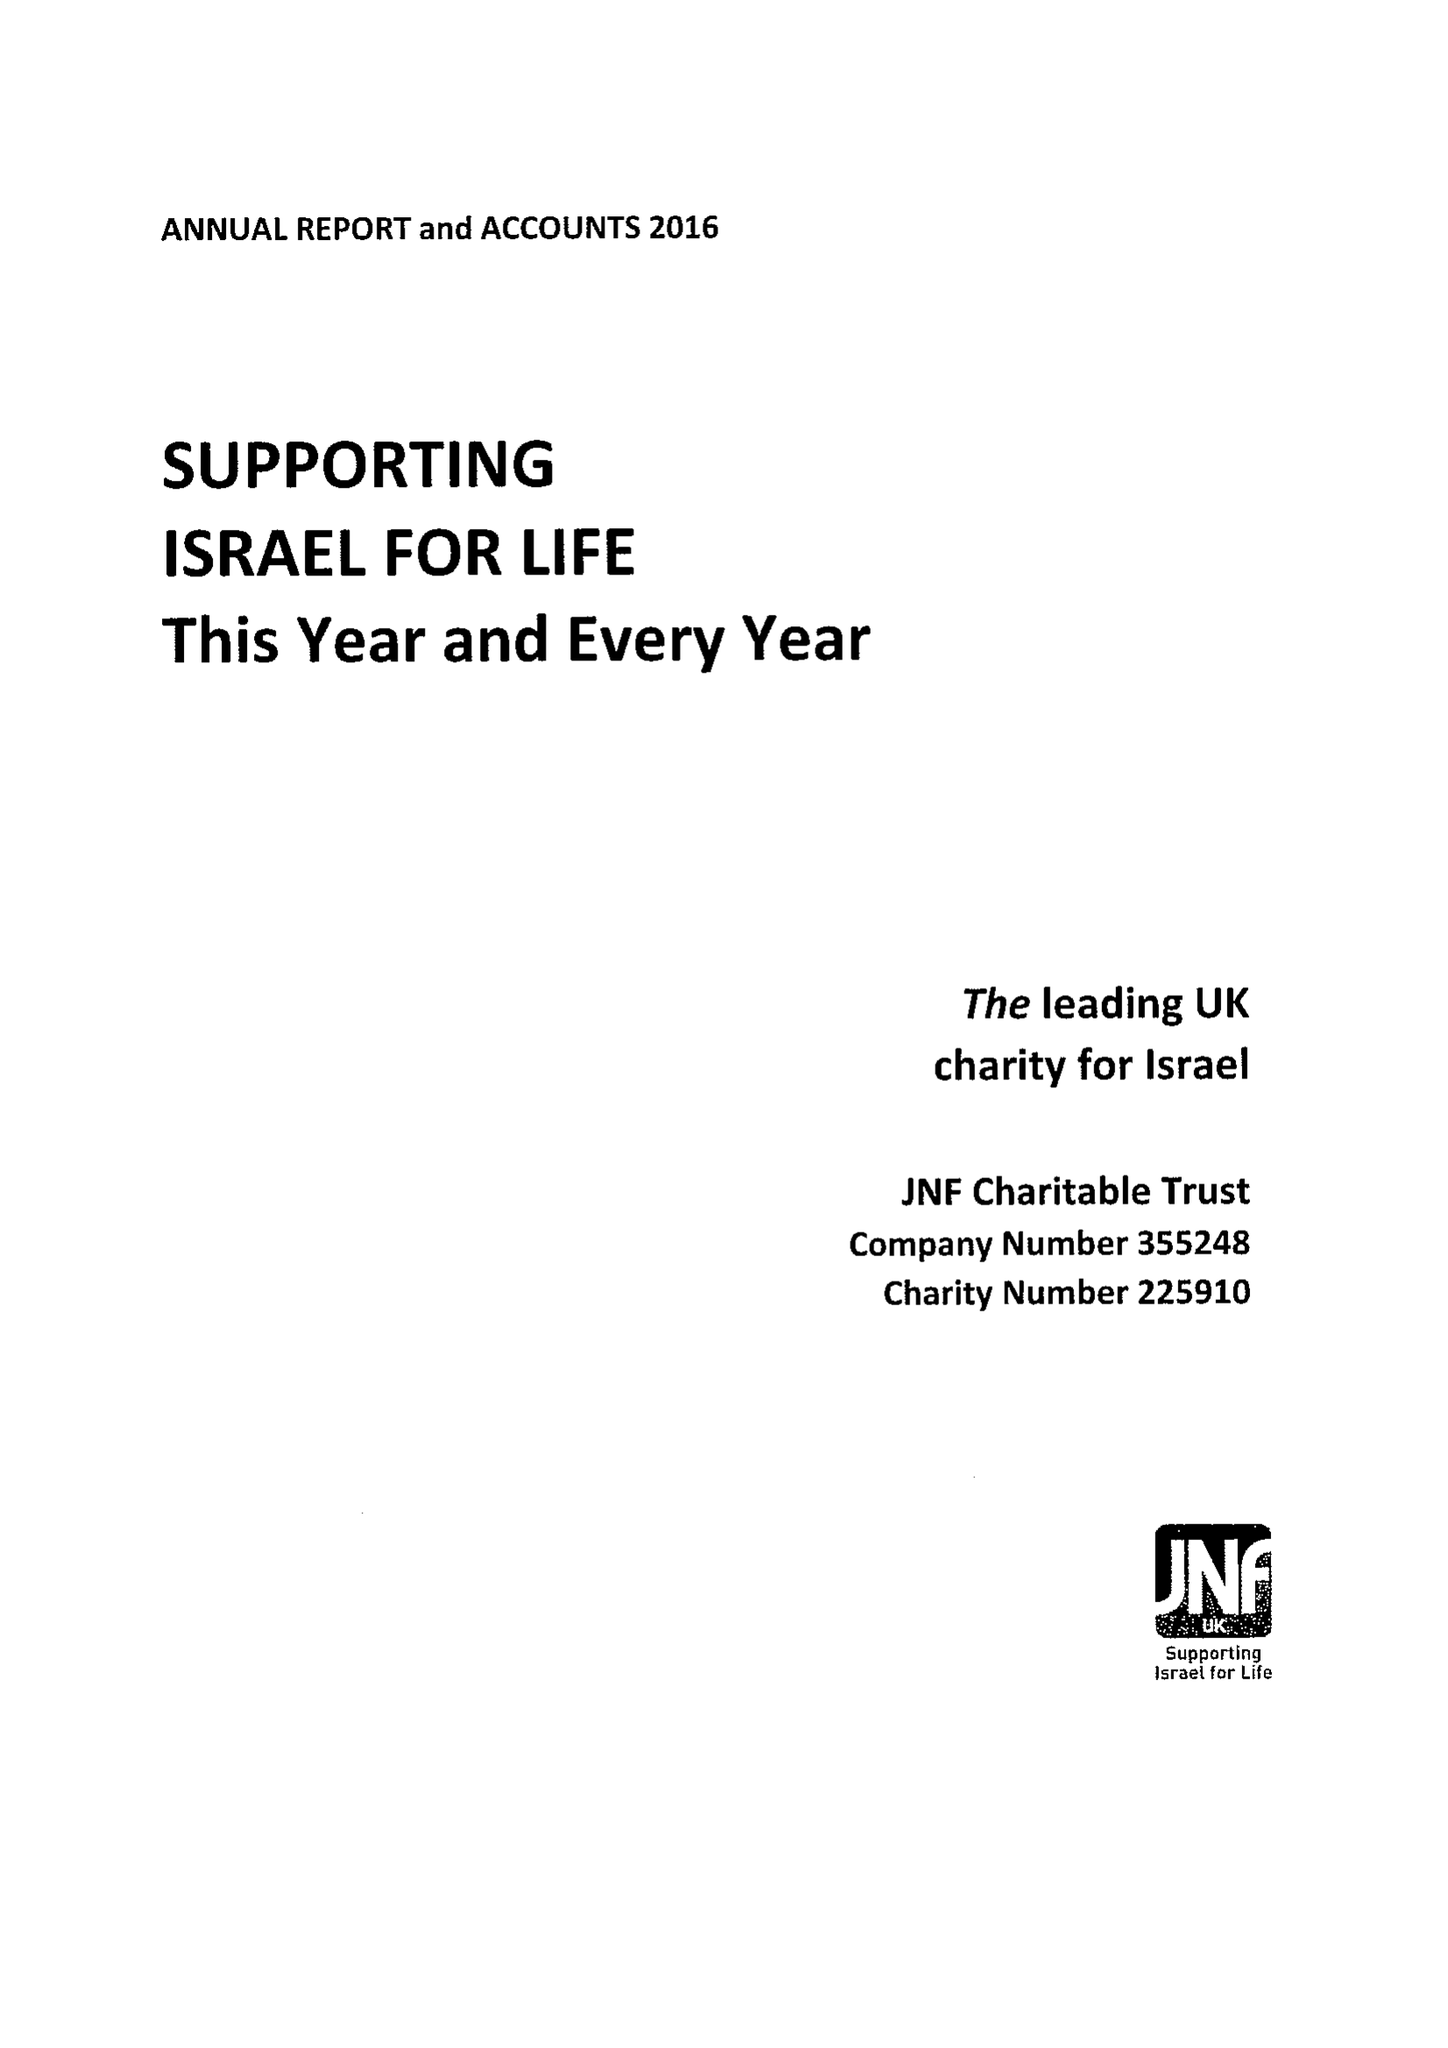What is the value for the address__postcode?
Answer the question using a single word or phrase. NW4 2BF 